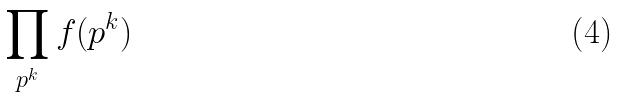<formula> <loc_0><loc_0><loc_500><loc_500>\prod _ { p ^ { k } } f ( p ^ { k } )</formula> 